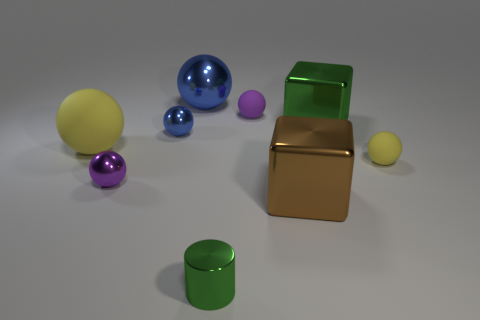Subtract all purple spheres. How many spheres are left? 4 Subtract all purple metal balls. How many balls are left? 5 Subtract all yellow balls. Subtract all gray cylinders. How many balls are left? 4 Subtract all large brown shiny blocks. Subtract all large matte things. How many objects are left? 7 Add 8 shiny cubes. How many shiny cubes are left? 10 Add 6 large blue shiny objects. How many large blue shiny objects exist? 7 Subtract 0 gray cylinders. How many objects are left? 9 Subtract all cylinders. How many objects are left? 8 